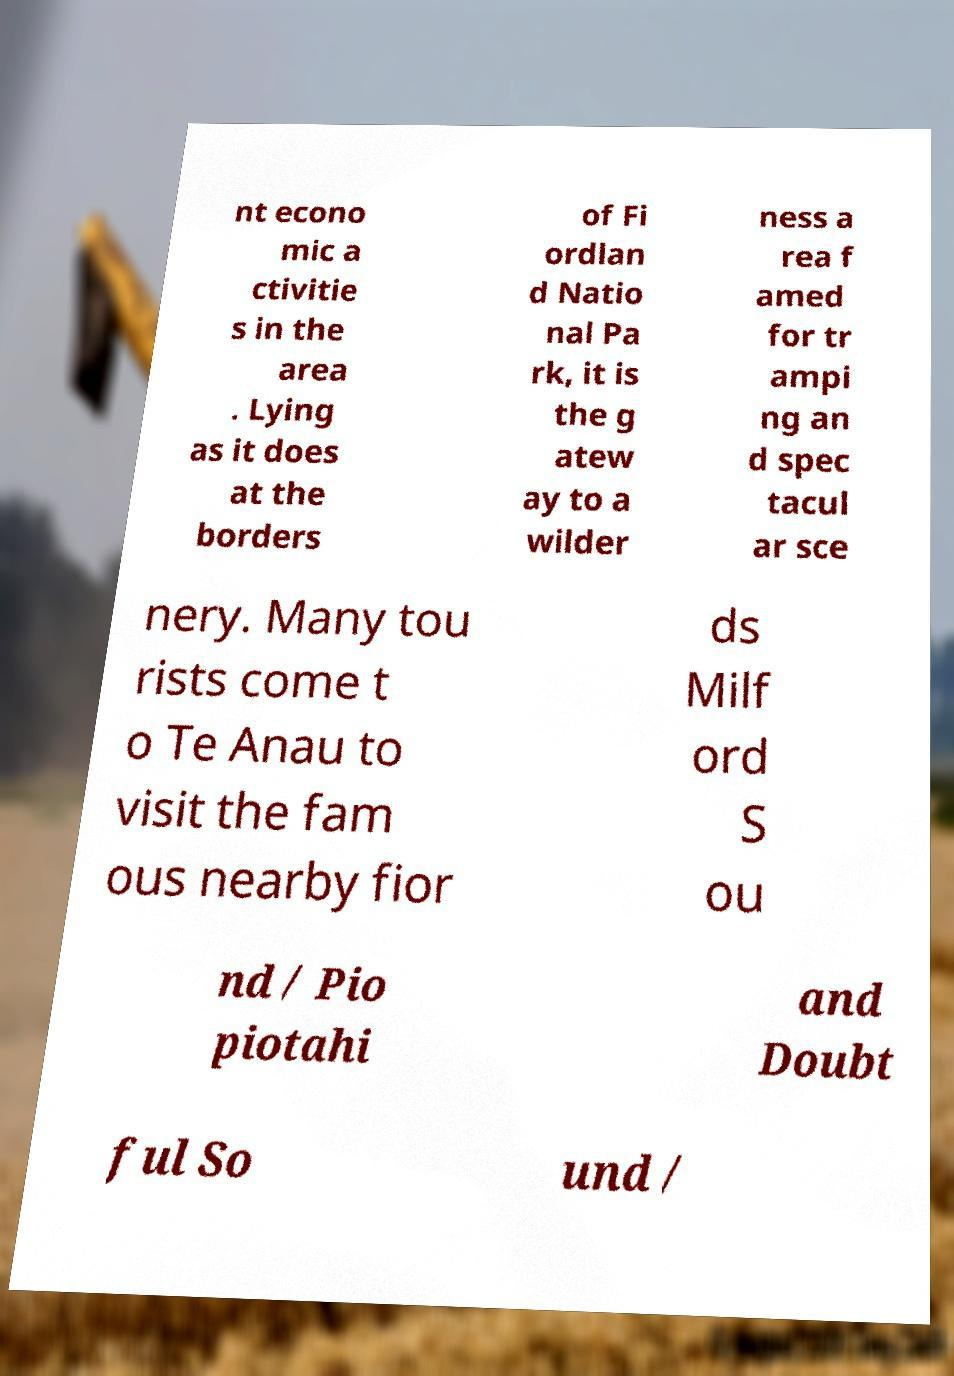I need the written content from this picture converted into text. Can you do that? nt econo mic a ctivitie s in the area . Lying as it does at the borders of Fi ordlan d Natio nal Pa rk, it is the g atew ay to a wilder ness a rea f amed for tr ampi ng an d spec tacul ar sce nery. Many tou rists come t o Te Anau to visit the fam ous nearby fior ds Milf ord S ou nd / Pio piotahi and Doubt ful So und / 